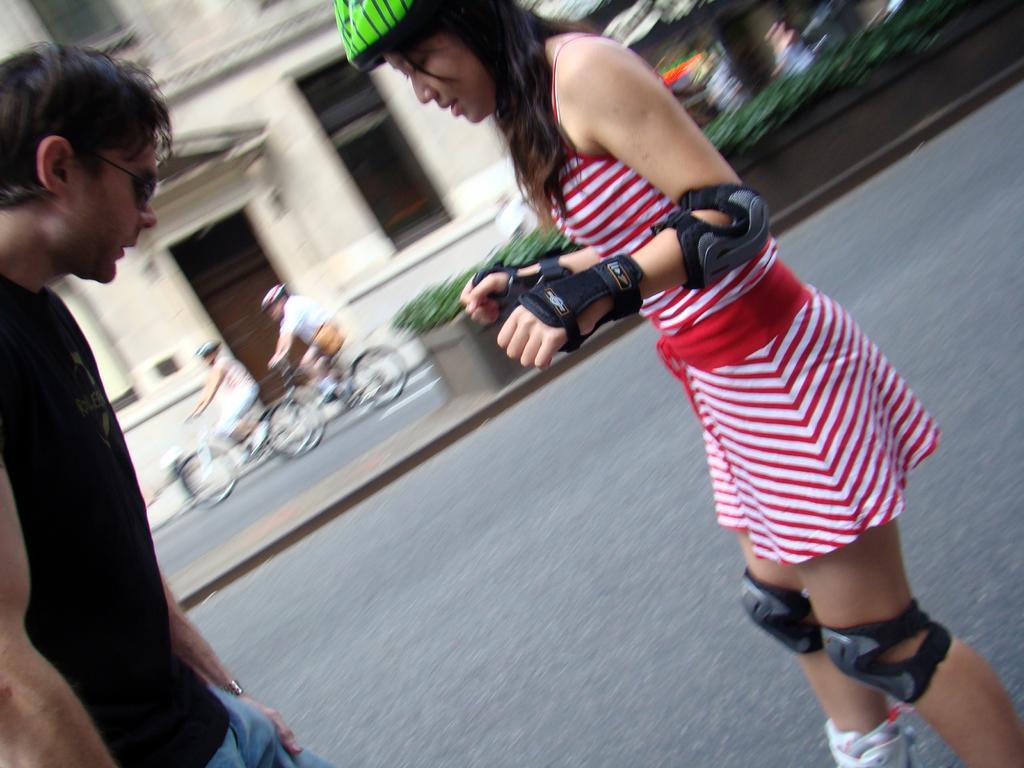Could you give a brief overview of what you see in this image? In this image we can see a few people, among them some are riding the bicycles on the road, in the background, we can see a building with windows and there are some plants. 